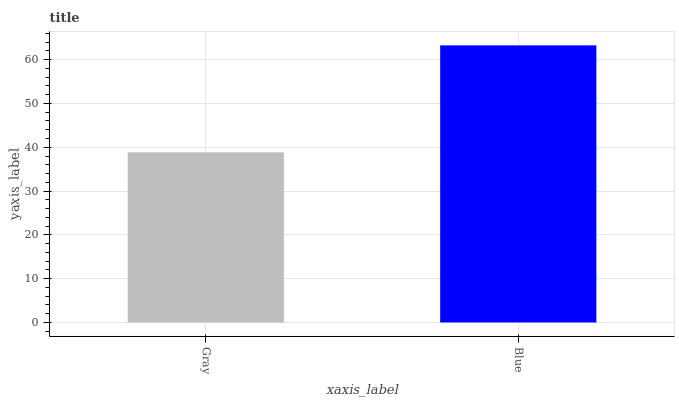Is Gray the minimum?
Answer yes or no. Yes. Is Blue the maximum?
Answer yes or no. Yes. Is Blue the minimum?
Answer yes or no. No. Is Blue greater than Gray?
Answer yes or no. Yes. Is Gray less than Blue?
Answer yes or no. Yes. Is Gray greater than Blue?
Answer yes or no. No. Is Blue less than Gray?
Answer yes or no. No. Is Blue the high median?
Answer yes or no. Yes. Is Gray the low median?
Answer yes or no. Yes. Is Gray the high median?
Answer yes or no. No. Is Blue the low median?
Answer yes or no. No. 